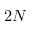Convert formula to latex. <formula><loc_0><loc_0><loc_500><loc_500>2 N</formula> 